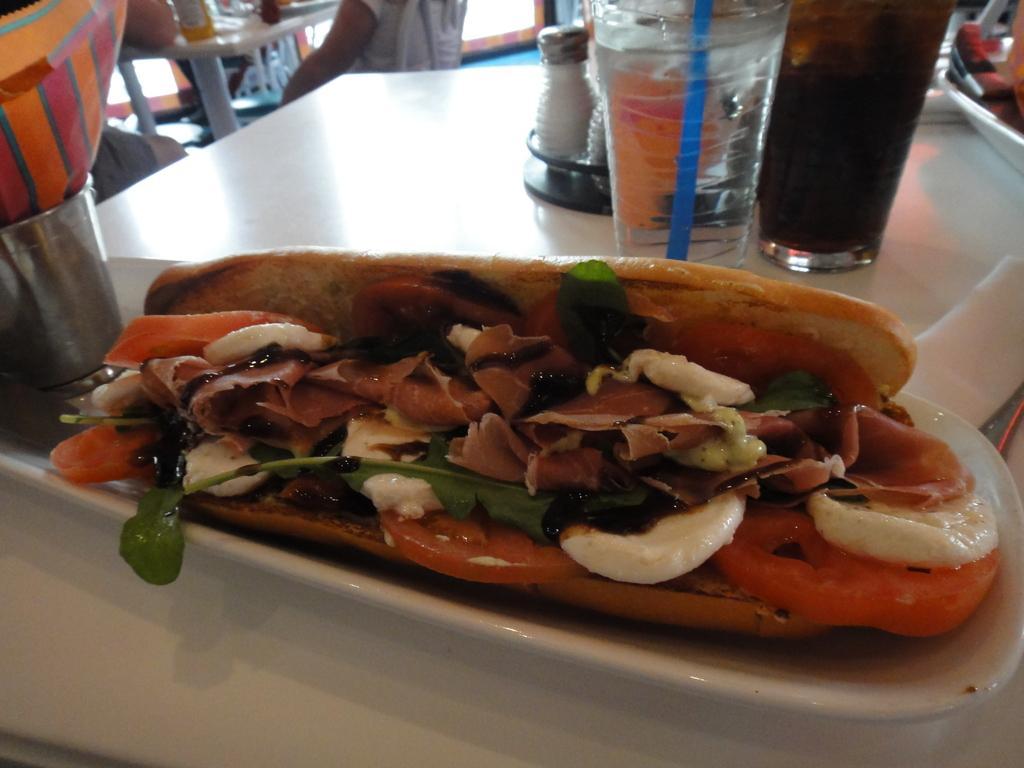Please provide a concise description of this image. In this image there is a table and we can see glasses, sprinklers, plate and some food placed on the table. In the background there are people sitting. 